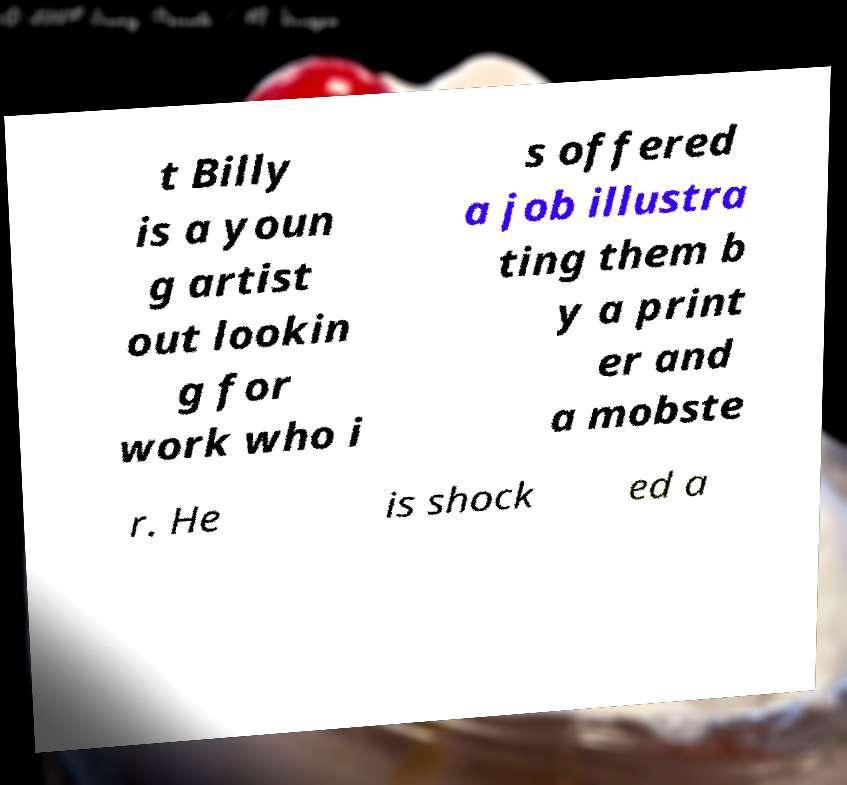What messages or text are displayed in this image? I need them in a readable, typed format. t Billy is a youn g artist out lookin g for work who i s offered a job illustra ting them b y a print er and a mobste r. He is shock ed a 